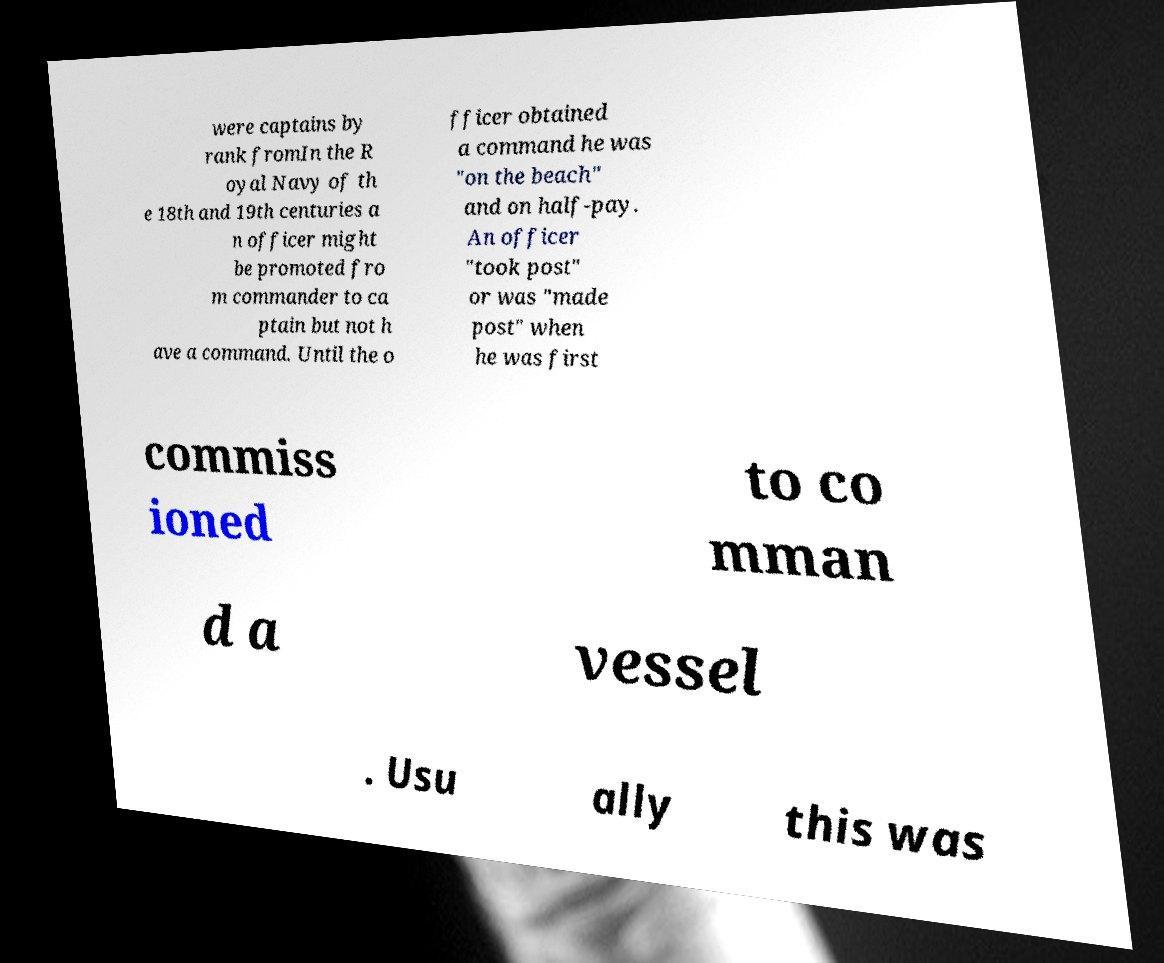There's text embedded in this image that I need extracted. Can you transcribe it verbatim? were captains by rank fromIn the R oyal Navy of th e 18th and 19th centuries a n officer might be promoted fro m commander to ca ptain but not h ave a command. Until the o fficer obtained a command he was "on the beach" and on half-pay. An officer "took post" or was "made post" when he was first commiss ioned to co mman d a vessel . Usu ally this was 